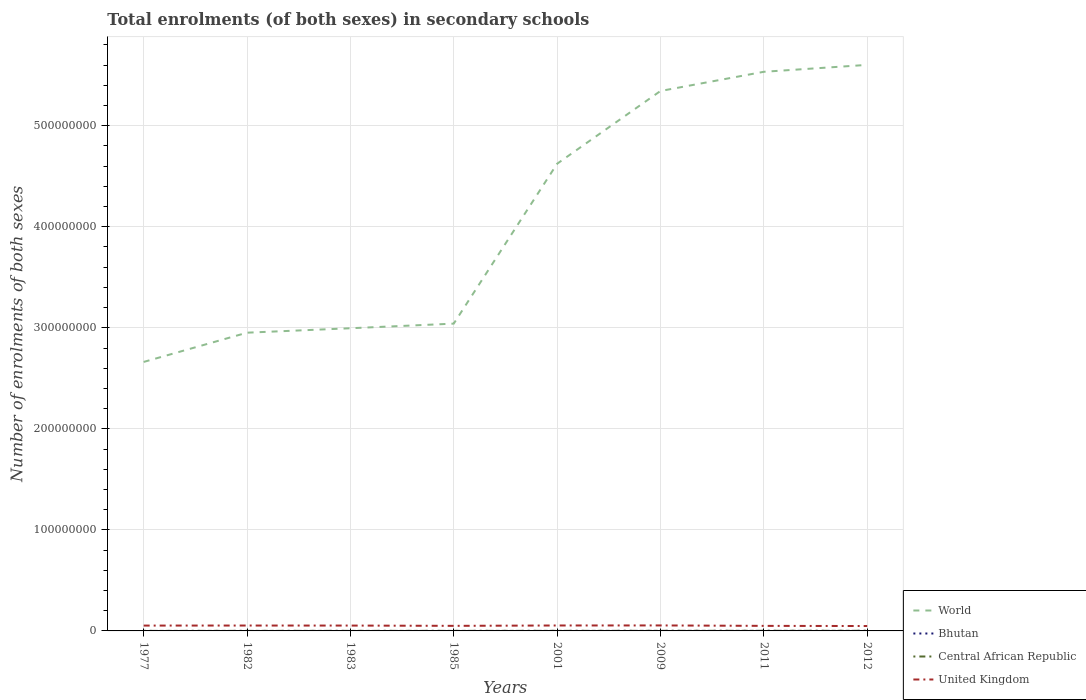How many different coloured lines are there?
Provide a short and direct response. 4. Does the line corresponding to World intersect with the line corresponding to Central African Republic?
Make the answer very short. No. Is the number of lines equal to the number of legend labels?
Offer a very short reply. Yes. Across all years, what is the maximum number of enrolments in secondary schools in World?
Offer a terse response. 2.66e+08. What is the total number of enrolments in secondary schools in World in the graph?
Give a very brief answer. -2.87e+08. What is the difference between the highest and the second highest number of enrolments in secondary schools in Bhutan?
Your answer should be compact. 6.45e+04. What is the difference between the highest and the lowest number of enrolments in secondary schools in Bhutan?
Offer a terse response. 4. How many lines are there?
Offer a very short reply. 4. What is the difference between two consecutive major ticks on the Y-axis?
Provide a short and direct response. 1.00e+08. Are the values on the major ticks of Y-axis written in scientific E-notation?
Your answer should be very brief. No. Does the graph contain grids?
Give a very brief answer. Yes. What is the title of the graph?
Ensure brevity in your answer.  Total enrolments (of both sexes) in secondary schools. What is the label or title of the X-axis?
Ensure brevity in your answer.  Years. What is the label or title of the Y-axis?
Ensure brevity in your answer.  Number of enrolments of both sexes. What is the Number of enrolments of both sexes in World in 1977?
Provide a succinct answer. 2.66e+08. What is the Number of enrolments of both sexes in Bhutan in 1977?
Ensure brevity in your answer.  1536. What is the Number of enrolments of both sexes in Central African Republic in 1977?
Give a very brief answer. 2.48e+04. What is the Number of enrolments of both sexes in United Kingdom in 1977?
Offer a very short reply. 5.29e+06. What is the Number of enrolments of both sexes in World in 1982?
Your answer should be compact. 2.95e+08. What is the Number of enrolments of both sexes in Bhutan in 1982?
Keep it short and to the point. 4408. What is the Number of enrolments of both sexes in Central African Republic in 1982?
Provide a succinct answer. 5.44e+04. What is the Number of enrolments of both sexes of United Kingdom in 1982?
Offer a very short reply. 5.33e+06. What is the Number of enrolments of both sexes of World in 1983?
Keep it short and to the point. 3.00e+08. What is the Number of enrolments of both sexes of Bhutan in 1983?
Your answer should be compact. 5298. What is the Number of enrolments of both sexes of Central African Republic in 1983?
Offer a very short reply. 5.54e+04. What is the Number of enrolments of both sexes in United Kingdom in 1983?
Give a very brief answer. 5.30e+06. What is the Number of enrolments of both sexes in World in 1985?
Provide a succinct answer. 3.04e+08. What is the Number of enrolments of both sexes in Bhutan in 1985?
Your answer should be very brief. 6094. What is the Number of enrolments of both sexes of Central African Republic in 1985?
Your answer should be very brief. 5.81e+04. What is the Number of enrolments of both sexes of United Kingdom in 1985?
Offer a terse response. 5.02e+06. What is the Number of enrolments of both sexes of World in 2001?
Your answer should be compact. 4.62e+08. What is the Number of enrolments of both sexes of Bhutan in 2001?
Provide a succinct answer. 2.91e+04. What is the Number of enrolments of both sexes in Central African Republic in 2001?
Your answer should be compact. 7.02e+04. What is the Number of enrolments of both sexes of United Kingdom in 2001?
Offer a terse response. 5.38e+06. What is the Number of enrolments of both sexes in World in 2009?
Your answer should be compact. 5.34e+08. What is the Number of enrolments of both sexes in Bhutan in 2009?
Provide a succinct answer. 5.65e+04. What is the Number of enrolments of both sexes of Central African Republic in 2009?
Make the answer very short. 9.33e+04. What is the Number of enrolments of both sexes in United Kingdom in 2009?
Make the answer very short. 5.43e+06. What is the Number of enrolments of both sexes of World in 2011?
Offer a terse response. 5.53e+08. What is the Number of enrolments of both sexes of Bhutan in 2011?
Provide a short and direct response. 6.28e+04. What is the Number of enrolments of both sexes in Central African Republic in 2011?
Give a very brief answer. 1.26e+05. What is the Number of enrolments of both sexes of United Kingdom in 2011?
Offer a very short reply. 5.00e+06. What is the Number of enrolments of both sexes of World in 2012?
Give a very brief answer. 5.60e+08. What is the Number of enrolments of both sexes of Bhutan in 2012?
Give a very brief answer. 6.61e+04. What is the Number of enrolments of both sexes of Central African Republic in 2012?
Provide a succinct answer. 1.26e+05. What is the Number of enrolments of both sexes of United Kingdom in 2012?
Give a very brief answer. 4.85e+06. Across all years, what is the maximum Number of enrolments of both sexes of World?
Ensure brevity in your answer.  5.60e+08. Across all years, what is the maximum Number of enrolments of both sexes of Bhutan?
Offer a terse response. 6.61e+04. Across all years, what is the maximum Number of enrolments of both sexes in Central African Republic?
Keep it short and to the point. 1.26e+05. Across all years, what is the maximum Number of enrolments of both sexes of United Kingdom?
Keep it short and to the point. 5.43e+06. Across all years, what is the minimum Number of enrolments of both sexes of World?
Make the answer very short. 2.66e+08. Across all years, what is the minimum Number of enrolments of both sexes of Bhutan?
Your answer should be compact. 1536. Across all years, what is the minimum Number of enrolments of both sexes of Central African Republic?
Ensure brevity in your answer.  2.48e+04. Across all years, what is the minimum Number of enrolments of both sexes in United Kingdom?
Provide a short and direct response. 4.85e+06. What is the total Number of enrolments of both sexes in World in the graph?
Offer a very short reply. 3.28e+09. What is the total Number of enrolments of both sexes in Bhutan in the graph?
Offer a very short reply. 2.32e+05. What is the total Number of enrolments of both sexes in Central African Republic in the graph?
Provide a short and direct response. 6.08e+05. What is the total Number of enrolments of both sexes in United Kingdom in the graph?
Give a very brief answer. 4.16e+07. What is the difference between the Number of enrolments of both sexes in World in 1977 and that in 1982?
Give a very brief answer. -2.89e+07. What is the difference between the Number of enrolments of both sexes in Bhutan in 1977 and that in 1982?
Provide a succinct answer. -2872. What is the difference between the Number of enrolments of both sexes of Central African Republic in 1977 and that in 1982?
Your answer should be compact. -2.96e+04. What is the difference between the Number of enrolments of both sexes in United Kingdom in 1977 and that in 1982?
Give a very brief answer. -4.41e+04. What is the difference between the Number of enrolments of both sexes of World in 1977 and that in 1983?
Offer a very short reply. -3.33e+07. What is the difference between the Number of enrolments of both sexes in Bhutan in 1977 and that in 1983?
Offer a terse response. -3762. What is the difference between the Number of enrolments of both sexes of Central African Republic in 1977 and that in 1983?
Ensure brevity in your answer.  -3.05e+04. What is the difference between the Number of enrolments of both sexes in United Kingdom in 1977 and that in 1983?
Ensure brevity in your answer.  -1.09e+04. What is the difference between the Number of enrolments of both sexes of World in 1977 and that in 1985?
Offer a terse response. -3.79e+07. What is the difference between the Number of enrolments of both sexes of Bhutan in 1977 and that in 1985?
Make the answer very short. -4558. What is the difference between the Number of enrolments of both sexes of Central African Republic in 1977 and that in 1985?
Keep it short and to the point. -3.33e+04. What is the difference between the Number of enrolments of both sexes in United Kingdom in 1977 and that in 1985?
Your response must be concise. 2.61e+05. What is the difference between the Number of enrolments of both sexes of World in 1977 and that in 2001?
Make the answer very short. -1.96e+08. What is the difference between the Number of enrolments of both sexes of Bhutan in 1977 and that in 2001?
Keep it short and to the point. -2.76e+04. What is the difference between the Number of enrolments of both sexes of Central African Republic in 1977 and that in 2001?
Give a very brief answer. -4.53e+04. What is the difference between the Number of enrolments of both sexes of United Kingdom in 1977 and that in 2001?
Offer a terse response. -9.18e+04. What is the difference between the Number of enrolments of both sexes of World in 1977 and that in 2009?
Your answer should be very brief. -2.68e+08. What is the difference between the Number of enrolments of both sexes of Bhutan in 1977 and that in 2009?
Keep it short and to the point. -5.50e+04. What is the difference between the Number of enrolments of both sexes of Central African Republic in 1977 and that in 2009?
Offer a terse response. -6.85e+04. What is the difference between the Number of enrolments of both sexes in United Kingdom in 1977 and that in 2009?
Give a very brief answer. -1.44e+05. What is the difference between the Number of enrolments of both sexes of World in 1977 and that in 2011?
Your response must be concise. -2.87e+08. What is the difference between the Number of enrolments of both sexes of Bhutan in 1977 and that in 2011?
Your answer should be compact. -6.12e+04. What is the difference between the Number of enrolments of both sexes of Central African Republic in 1977 and that in 2011?
Keep it short and to the point. -1.01e+05. What is the difference between the Number of enrolments of both sexes of United Kingdom in 1977 and that in 2011?
Give a very brief answer. 2.85e+05. What is the difference between the Number of enrolments of both sexes of World in 1977 and that in 2012?
Ensure brevity in your answer.  -2.94e+08. What is the difference between the Number of enrolments of both sexes of Bhutan in 1977 and that in 2012?
Give a very brief answer. -6.45e+04. What is the difference between the Number of enrolments of both sexes of Central African Republic in 1977 and that in 2012?
Your response must be concise. -1.01e+05. What is the difference between the Number of enrolments of both sexes of United Kingdom in 1977 and that in 2012?
Your answer should be compact. 4.36e+05. What is the difference between the Number of enrolments of both sexes in World in 1982 and that in 1983?
Ensure brevity in your answer.  -4.40e+06. What is the difference between the Number of enrolments of both sexes of Bhutan in 1982 and that in 1983?
Make the answer very short. -890. What is the difference between the Number of enrolments of both sexes of Central African Republic in 1982 and that in 1983?
Your response must be concise. -968. What is the difference between the Number of enrolments of both sexes in United Kingdom in 1982 and that in 1983?
Ensure brevity in your answer.  3.33e+04. What is the difference between the Number of enrolments of both sexes in World in 1982 and that in 1985?
Offer a terse response. -8.98e+06. What is the difference between the Number of enrolments of both sexes in Bhutan in 1982 and that in 1985?
Ensure brevity in your answer.  -1686. What is the difference between the Number of enrolments of both sexes of Central African Republic in 1982 and that in 1985?
Your response must be concise. -3704. What is the difference between the Number of enrolments of both sexes of United Kingdom in 1982 and that in 1985?
Offer a very short reply. 3.05e+05. What is the difference between the Number of enrolments of both sexes in World in 1982 and that in 2001?
Offer a very short reply. -1.67e+08. What is the difference between the Number of enrolments of both sexes of Bhutan in 1982 and that in 2001?
Make the answer very short. -2.47e+04. What is the difference between the Number of enrolments of both sexes of Central African Republic in 1982 and that in 2001?
Offer a terse response. -1.58e+04. What is the difference between the Number of enrolments of both sexes in United Kingdom in 1982 and that in 2001?
Your answer should be very brief. -4.77e+04. What is the difference between the Number of enrolments of both sexes of World in 1982 and that in 2009?
Give a very brief answer. -2.39e+08. What is the difference between the Number of enrolments of both sexes of Bhutan in 1982 and that in 2009?
Your answer should be very brief. -5.21e+04. What is the difference between the Number of enrolments of both sexes in Central African Republic in 1982 and that in 2009?
Make the answer very short. -3.89e+04. What is the difference between the Number of enrolments of both sexes of United Kingdom in 1982 and that in 2009?
Your answer should be very brief. -1.00e+05. What is the difference between the Number of enrolments of both sexes in World in 1982 and that in 2011?
Your answer should be very brief. -2.58e+08. What is the difference between the Number of enrolments of both sexes in Bhutan in 1982 and that in 2011?
Your answer should be compact. -5.84e+04. What is the difference between the Number of enrolments of both sexes in Central African Republic in 1982 and that in 2011?
Provide a succinct answer. -7.16e+04. What is the difference between the Number of enrolments of both sexes of United Kingdom in 1982 and that in 2011?
Offer a very short reply. 3.29e+05. What is the difference between the Number of enrolments of both sexes in World in 1982 and that in 2012?
Keep it short and to the point. -2.65e+08. What is the difference between the Number of enrolments of both sexes in Bhutan in 1982 and that in 2012?
Ensure brevity in your answer.  -6.17e+04. What is the difference between the Number of enrolments of both sexes of Central African Republic in 1982 and that in 2012?
Offer a terse response. -7.15e+04. What is the difference between the Number of enrolments of both sexes in United Kingdom in 1982 and that in 2012?
Give a very brief answer. 4.80e+05. What is the difference between the Number of enrolments of both sexes in World in 1983 and that in 1985?
Give a very brief answer. -4.58e+06. What is the difference between the Number of enrolments of both sexes of Bhutan in 1983 and that in 1985?
Give a very brief answer. -796. What is the difference between the Number of enrolments of both sexes of Central African Republic in 1983 and that in 1985?
Your answer should be very brief. -2736. What is the difference between the Number of enrolments of both sexes of United Kingdom in 1983 and that in 1985?
Keep it short and to the point. 2.72e+05. What is the difference between the Number of enrolments of both sexes of World in 1983 and that in 2001?
Give a very brief answer. -1.63e+08. What is the difference between the Number of enrolments of both sexes of Bhutan in 1983 and that in 2001?
Offer a very short reply. -2.38e+04. What is the difference between the Number of enrolments of both sexes of Central African Republic in 1983 and that in 2001?
Keep it short and to the point. -1.48e+04. What is the difference between the Number of enrolments of both sexes in United Kingdom in 1983 and that in 2001?
Offer a terse response. -8.10e+04. What is the difference between the Number of enrolments of both sexes of World in 1983 and that in 2009?
Your answer should be very brief. -2.35e+08. What is the difference between the Number of enrolments of both sexes of Bhutan in 1983 and that in 2009?
Your answer should be very brief. -5.12e+04. What is the difference between the Number of enrolments of both sexes in Central African Republic in 1983 and that in 2009?
Offer a very short reply. -3.80e+04. What is the difference between the Number of enrolments of both sexes in United Kingdom in 1983 and that in 2009?
Your answer should be compact. -1.34e+05. What is the difference between the Number of enrolments of both sexes of World in 1983 and that in 2011?
Your answer should be very brief. -2.54e+08. What is the difference between the Number of enrolments of both sexes in Bhutan in 1983 and that in 2011?
Keep it short and to the point. -5.75e+04. What is the difference between the Number of enrolments of both sexes in Central African Republic in 1983 and that in 2011?
Your response must be concise. -7.06e+04. What is the difference between the Number of enrolments of both sexes in United Kingdom in 1983 and that in 2011?
Your answer should be compact. 2.96e+05. What is the difference between the Number of enrolments of both sexes of World in 1983 and that in 2012?
Your answer should be compact. -2.61e+08. What is the difference between the Number of enrolments of both sexes in Bhutan in 1983 and that in 2012?
Your response must be concise. -6.08e+04. What is the difference between the Number of enrolments of both sexes of Central African Republic in 1983 and that in 2012?
Offer a terse response. -7.05e+04. What is the difference between the Number of enrolments of both sexes of United Kingdom in 1983 and that in 2012?
Give a very brief answer. 4.47e+05. What is the difference between the Number of enrolments of both sexes in World in 1985 and that in 2001?
Your answer should be compact. -1.58e+08. What is the difference between the Number of enrolments of both sexes of Bhutan in 1985 and that in 2001?
Your answer should be very brief. -2.30e+04. What is the difference between the Number of enrolments of both sexes of Central African Republic in 1985 and that in 2001?
Give a very brief answer. -1.21e+04. What is the difference between the Number of enrolments of both sexes in United Kingdom in 1985 and that in 2001?
Provide a succinct answer. -3.53e+05. What is the difference between the Number of enrolments of both sexes of World in 1985 and that in 2009?
Offer a very short reply. -2.30e+08. What is the difference between the Number of enrolments of both sexes of Bhutan in 1985 and that in 2009?
Provide a short and direct response. -5.04e+04. What is the difference between the Number of enrolments of both sexes in Central African Republic in 1985 and that in 2009?
Your answer should be very brief. -3.52e+04. What is the difference between the Number of enrolments of both sexes of United Kingdom in 1985 and that in 2009?
Keep it short and to the point. -4.06e+05. What is the difference between the Number of enrolments of both sexes in World in 1985 and that in 2011?
Keep it short and to the point. -2.49e+08. What is the difference between the Number of enrolments of both sexes of Bhutan in 1985 and that in 2011?
Your answer should be compact. -5.67e+04. What is the difference between the Number of enrolments of both sexes in Central African Republic in 1985 and that in 2011?
Provide a short and direct response. -6.79e+04. What is the difference between the Number of enrolments of both sexes of United Kingdom in 1985 and that in 2011?
Provide a succinct answer. 2.37e+04. What is the difference between the Number of enrolments of both sexes of World in 1985 and that in 2012?
Your answer should be compact. -2.56e+08. What is the difference between the Number of enrolments of both sexes in Bhutan in 1985 and that in 2012?
Offer a terse response. -6.00e+04. What is the difference between the Number of enrolments of both sexes of Central African Republic in 1985 and that in 2012?
Provide a short and direct response. -6.78e+04. What is the difference between the Number of enrolments of both sexes of United Kingdom in 1985 and that in 2012?
Offer a terse response. 1.75e+05. What is the difference between the Number of enrolments of both sexes of World in 2001 and that in 2009?
Offer a terse response. -7.20e+07. What is the difference between the Number of enrolments of both sexes in Bhutan in 2001 and that in 2009?
Offer a terse response. -2.74e+04. What is the difference between the Number of enrolments of both sexes in Central African Republic in 2001 and that in 2009?
Offer a terse response. -2.32e+04. What is the difference between the Number of enrolments of both sexes of United Kingdom in 2001 and that in 2009?
Make the answer very short. -5.27e+04. What is the difference between the Number of enrolments of both sexes in World in 2001 and that in 2011?
Give a very brief answer. -9.10e+07. What is the difference between the Number of enrolments of both sexes in Bhutan in 2001 and that in 2011?
Ensure brevity in your answer.  -3.37e+04. What is the difference between the Number of enrolments of both sexes in Central African Republic in 2001 and that in 2011?
Your answer should be compact. -5.59e+04. What is the difference between the Number of enrolments of both sexes in United Kingdom in 2001 and that in 2011?
Make the answer very short. 3.77e+05. What is the difference between the Number of enrolments of both sexes of World in 2001 and that in 2012?
Make the answer very short. -9.79e+07. What is the difference between the Number of enrolments of both sexes of Bhutan in 2001 and that in 2012?
Provide a succinct answer. -3.70e+04. What is the difference between the Number of enrolments of both sexes in Central African Republic in 2001 and that in 2012?
Give a very brief answer. -5.57e+04. What is the difference between the Number of enrolments of both sexes of United Kingdom in 2001 and that in 2012?
Your answer should be very brief. 5.28e+05. What is the difference between the Number of enrolments of both sexes of World in 2009 and that in 2011?
Provide a short and direct response. -1.90e+07. What is the difference between the Number of enrolments of both sexes of Bhutan in 2009 and that in 2011?
Your answer should be very brief. -6225. What is the difference between the Number of enrolments of both sexes of Central African Republic in 2009 and that in 2011?
Make the answer very short. -3.27e+04. What is the difference between the Number of enrolments of both sexes of United Kingdom in 2009 and that in 2011?
Keep it short and to the point. 4.29e+05. What is the difference between the Number of enrolments of both sexes in World in 2009 and that in 2012?
Make the answer very short. -2.58e+07. What is the difference between the Number of enrolments of both sexes of Bhutan in 2009 and that in 2012?
Keep it short and to the point. -9529. What is the difference between the Number of enrolments of both sexes of Central African Republic in 2009 and that in 2012?
Offer a terse response. -3.26e+04. What is the difference between the Number of enrolments of both sexes of United Kingdom in 2009 and that in 2012?
Keep it short and to the point. 5.80e+05. What is the difference between the Number of enrolments of both sexes in World in 2011 and that in 2012?
Provide a short and direct response. -6.84e+06. What is the difference between the Number of enrolments of both sexes in Bhutan in 2011 and that in 2012?
Your response must be concise. -3304. What is the difference between the Number of enrolments of both sexes in Central African Republic in 2011 and that in 2012?
Provide a short and direct response. 110. What is the difference between the Number of enrolments of both sexes in United Kingdom in 2011 and that in 2012?
Make the answer very short. 1.51e+05. What is the difference between the Number of enrolments of both sexes in World in 1977 and the Number of enrolments of both sexes in Bhutan in 1982?
Ensure brevity in your answer.  2.66e+08. What is the difference between the Number of enrolments of both sexes in World in 1977 and the Number of enrolments of both sexes in Central African Republic in 1982?
Keep it short and to the point. 2.66e+08. What is the difference between the Number of enrolments of both sexes of World in 1977 and the Number of enrolments of both sexes of United Kingdom in 1982?
Keep it short and to the point. 2.61e+08. What is the difference between the Number of enrolments of both sexes of Bhutan in 1977 and the Number of enrolments of both sexes of Central African Republic in 1982?
Ensure brevity in your answer.  -5.29e+04. What is the difference between the Number of enrolments of both sexes in Bhutan in 1977 and the Number of enrolments of both sexes in United Kingdom in 1982?
Your answer should be compact. -5.33e+06. What is the difference between the Number of enrolments of both sexes of Central African Republic in 1977 and the Number of enrolments of both sexes of United Kingdom in 1982?
Offer a terse response. -5.30e+06. What is the difference between the Number of enrolments of both sexes of World in 1977 and the Number of enrolments of both sexes of Bhutan in 1983?
Provide a succinct answer. 2.66e+08. What is the difference between the Number of enrolments of both sexes of World in 1977 and the Number of enrolments of both sexes of Central African Republic in 1983?
Offer a terse response. 2.66e+08. What is the difference between the Number of enrolments of both sexes of World in 1977 and the Number of enrolments of both sexes of United Kingdom in 1983?
Your answer should be compact. 2.61e+08. What is the difference between the Number of enrolments of both sexes of Bhutan in 1977 and the Number of enrolments of both sexes of Central African Republic in 1983?
Give a very brief answer. -5.38e+04. What is the difference between the Number of enrolments of both sexes in Bhutan in 1977 and the Number of enrolments of both sexes in United Kingdom in 1983?
Keep it short and to the point. -5.29e+06. What is the difference between the Number of enrolments of both sexes in Central African Republic in 1977 and the Number of enrolments of both sexes in United Kingdom in 1983?
Provide a short and direct response. -5.27e+06. What is the difference between the Number of enrolments of both sexes of World in 1977 and the Number of enrolments of both sexes of Bhutan in 1985?
Your answer should be compact. 2.66e+08. What is the difference between the Number of enrolments of both sexes in World in 1977 and the Number of enrolments of both sexes in Central African Republic in 1985?
Keep it short and to the point. 2.66e+08. What is the difference between the Number of enrolments of both sexes of World in 1977 and the Number of enrolments of both sexes of United Kingdom in 1985?
Your response must be concise. 2.61e+08. What is the difference between the Number of enrolments of both sexes of Bhutan in 1977 and the Number of enrolments of both sexes of Central African Republic in 1985?
Your answer should be very brief. -5.66e+04. What is the difference between the Number of enrolments of both sexes in Bhutan in 1977 and the Number of enrolments of both sexes in United Kingdom in 1985?
Your answer should be compact. -5.02e+06. What is the difference between the Number of enrolments of both sexes in Central African Republic in 1977 and the Number of enrolments of both sexes in United Kingdom in 1985?
Your answer should be very brief. -5.00e+06. What is the difference between the Number of enrolments of both sexes in World in 1977 and the Number of enrolments of both sexes in Bhutan in 2001?
Provide a short and direct response. 2.66e+08. What is the difference between the Number of enrolments of both sexes in World in 1977 and the Number of enrolments of both sexes in Central African Republic in 2001?
Your answer should be compact. 2.66e+08. What is the difference between the Number of enrolments of both sexes of World in 1977 and the Number of enrolments of both sexes of United Kingdom in 2001?
Your response must be concise. 2.61e+08. What is the difference between the Number of enrolments of both sexes in Bhutan in 1977 and the Number of enrolments of both sexes in Central African Republic in 2001?
Offer a very short reply. -6.86e+04. What is the difference between the Number of enrolments of both sexes in Bhutan in 1977 and the Number of enrolments of both sexes in United Kingdom in 2001?
Provide a succinct answer. -5.38e+06. What is the difference between the Number of enrolments of both sexes in Central African Republic in 1977 and the Number of enrolments of both sexes in United Kingdom in 2001?
Your answer should be compact. -5.35e+06. What is the difference between the Number of enrolments of both sexes in World in 1977 and the Number of enrolments of both sexes in Bhutan in 2009?
Your response must be concise. 2.66e+08. What is the difference between the Number of enrolments of both sexes in World in 1977 and the Number of enrolments of both sexes in Central African Republic in 2009?
Keep it short and to the point. 2.66e+08. What is the difference between the Number of enrolments of both sexes of World in 1977 and the Number of enrolments of both sexes of United Kingdom in 2009?
Keep it short and to the point. 2.61e+08. What is the difference between the Number of enrolments of both sexes in Bhutan in 1977 and the Number of enrolments of both sexes in Central African Republic in 2009?
Provide a succinct answer. -9.18e+04. What is the difference between the Number of enrolments of both sexes in Bhutan in 1977 and the Number of enrolments of both sexes in United Kingdom in 2009?
Keep it short and to the point. -5.43e+06. What is the difference between the Number of enrolments of both sexes of Central African Republic in 1977 and the Number of enrolments of both sexes of United Kingdom in 2009?
Your answer should be very brief. -5.40e+06. What is the difference between the Number of enrolments of both sexes of World in 1977 and the Number of enrolments of both sexes of Bhutan in 2011?
Provide a succinct answer. 2.66e+08. What is the difference between the Number of enrolments of both sexes of World in 1977 and the Number of enrolments of both sexes of Central African Republic in 2011?
Your answer should be compact. 2.66e+08. What is the difference between the Number of enrolments of both sexes of World in 1977 and the Number of enrolments of both sexes of United Kingdom in 2011?
Make the answer very short. 2.61e+08. What is the difference between the Number of enrolments of both sexes of Bhutan in 1977 and the Number of enrolments of both sexes of Central African Republic in 2011?
Provide a succinct answer. -1.24e+05. What is the difference between the Number of enrolments of both sexes in Bhutan in 1977 and the Number of enrolments of both sexes in United Kingdom in 2011?
Provide a short and direct response. -5.00e+06. What is the difference between the Number of enrolments of both sexes in Central African Republic in 1977 and the Number of enrolments of both sexes in United Kingdom in 2011?
Offer a terse response. -4.98e+06. What is the difference between the Number of enrolments of both sexes of World in 1977 and the Number of enrolments of both sexes of Bhutan in 2012?
Make the answer very short. 2.66e+08. What is the difference between the Number of enrolments of both sexes of World in 1977 and the Number of enrolments of both sexes of Central African Republic in 2012?
Your response must be concise. 2.66e+08. What is the difference between the Number of enrolments of both sexes of World in 1977 and the Number of enrolments of both sexes of United Kingdom in 2012?
Make the answer very short. 2.61e+08. What is the difference between the Number of enrolments of both sexes of Bhutan in 1977 and the Number of enrolments of both sexes of Central African Republic in 2012?
Your response must be concise. -1.24e+05. What is the difference between the Number of enrolments of both sexes of Bhutan in 1977 and the Number of enrolments of both sexes of United Kingdom in 2012?
Your response must be concise. -4.85e+06. What is the difference between the Number of enrolments of both sexes in Central African Republic in 1977 and the Number of enrolments of both sexes in United Kingdom in 2012?
Give a very brief answer. -4.82e+06. What is the difference between the Number of enrolments of both sexes in World in 1982 and the Number of enrolments of both sexes in Bhutan in 1983?
Provide a succinct answer. 2.95e+08. What is the difference between the Number of enrolments of both sexes of World in 1982 and the Number of enrolments of both sexes of Central African Republic in 1983?
Your answer should be compact. 2.95e+08. What is the difference between the Number of enrolments of both sexes in World in 1982 and the Number of enrolments of both sexes in United Kingdom in 1983?
Provide a short and direct response. 2.90e+08. What is the difference between the Number of enrolments of both sexes of Bhutan in 1982 and the Number of enrolments of both sexes of Central African Republic in 1983?
Make the answer very short. -5.10e+04. What is the difference between the Number of enrolments of both sexes of Bhutan in 1982 and the Number of enrolments of both sexes of United Kingdom in 1983?
Your answer should be very brief. -5.29e+06. What is the difference between the Number of enrolments of both sexes of Central African Republic in 1982 and the Number of enrolments of both sexes of United Kingdom in 1983?
Ensure brevity in your answer.  -5.24e+06. What is the difference between the Number of enrolments of both sexes in World in 1982 and the Number of enrolments of both sexes in Bhutan in 1985?
Offer a very short reply. 2.95e+08. What is the difference between the Number of enrolments of both sexes in World in 1982 and the Number of enrolments of both sexes in Central African Republic in 1985?
Make the answer very short. 2.95e+08. What is the difference between the Number of enrolments of both sexes of World in 1982 and the Number of enrolments of both sexes of United Kingdom in 1985?
Your answer should be very brief. 2.90e+08. What is the difference between the Number of enrolments of both sexes of Bhutan in 1982 and the Number of enrolments of both sexes of Central African Republic in 1985?
Offer a terse response. -5.37e+04. What is the difference between the Number of enrolments of both sexes in Bhutan in 1982 and the Number of enrolments of both sexes in United Kingdom in 1985?
Offer a terse response. -5.02e+06. What is the difference between the Number of enrolments of both sexes in Central African Republic in 1982 and the Number of enrolments of both sexes in United Kingdom in 1985?
Provide a succinct answer. -4.97e+06. What is the difference between the Number of enrolments of both sexes of World in 1982 and the Number of enrolments of both sexes of Bhutan in 2001?
Provide a succinct answer. 2.95e+08. What is the difference between the Number of enrolments of both sexes of World in 1982 and the Number of enrolments of both sexes of Central African Republic in 2001?
Provide a succinct answer. 2.95e+08. What is the difference between the Number of enrolments of both sexes of World in 1982 and the Number of enrolments of both sexes of United Kingdom in 2001?
Your response must be concise. 2.90e+08. What is the difference between the Number of enrolments of both sexes in Bhutan in 1982 and the Number of enrolments of both sexes in Central African Republic in 2001?
Make the answer very short. -6.58e+04. What is the difference between the Number of enrolments of both sexes in Bhutan in 1982 and the Number of enrolments of both sexes in United Kingdom in 2001?
Your answer should be very brief. -5.37e+06. What is the difference between the Number of enrolments of both sexes of Central African Republic in 1982 and the Number of enrolments of both sexes of United Kingdom in 2001?
Offer a very short reply. -5.32e+06. What is the difference between the Number of enrolments of both sexes of World in 1982 and the Number of enrolments of both sexes of Bhutan in 2009?
Provide a short and direct response. 2.95e+08. What is the difference between the Number of enrolments of both sexes of World in 1982 and the Number of enrolments of both sexes of Central African Republic in 2009?
Give a very brief answer. 2.95e+08. What is the difference between the Number of enrolments of both sexes in World in 1982 and the Number of enrolments of both sexes in United Kingdom in 2009?
Keep it short and to the point. 2.90e+08. What is the difference between the Number of enrolments of both sexes of Bhutan in 1982 and the Number of enrolments of both sexes of Central African Republic in 2009?
Give a very brief answer. -8.89e+04. What is the difference between the Number of enrolments of both sexes of Bhutan in 1982 and the Number of enrolments of both sexes of United Kingdom in 2009?
Your response must be concise. -5.43e+06. What is the difference between the Number of enrolments of both sexes in Central African Republic in 1982 and the Number of enrolments of both sexes in United Kingdom in 2009?
Keep it short and to the point. -5.38e+06. What is the difference between the Number of enrolments of both sexes in World in 1982 and the Number of enrolments of both sexes in Bhutan in 2011?
Keep it short and to the point. 2.95e+08. What is the difference between the Number of enrolments of both sexes in World in 1982 and the Number of enrolments of both sexes in Central African Republic in 2011?
Give a very brief answer. 2.95e+08. What is the difference between the Number of enrolments of both sexes in World in 1982 and the Number of enrolments of both sexes in United Kingdom in 2011?
Your answer should be compact. 2.90e+08. What is the difference between the Number of enrolments of both sexes of Bhutan in 1982 and the Number of enrolments of both sexes of Central African Republic in 2011?
Offer a very short reply. -1.22e+05. What is the difference between the Number of enrolments of both sexes of Bhutan in 1982 and the Number of enrolments of both sexes of United Kingdom in 2011?
Make the answer very short. -5.00e+06. What is the difference between the Number of enrolments of both sexes in Central African Republic in 1982 and the Number of enrolments of both sexes in United Kingdom in 2011?
Your response must be concise. -4.95e+06. What is the difference between the Number of enrolments of both sexes in World in 1982 and the Number of enrolments of both sexes in Bhutan in 2012?
Your answer should be compact. 2.95e+08. What is the difference between the Number of enrolments of both sexes of World in 1982 and the Number of enrolments of both sexes of Central African Republic in 2012?
Give a very brief answer. 2.95e+08. What is the difference between the Number of enrolments of both sexes of World in 1982 and the Number of enrolments of both sexes of United Kingdom in 2012?
Provide a short and direct response. 2.90e+08. What is the difference between the Number of enrolments of both sexes in Bhutan in 1982 and the Number of enrolments of both sexes in Central African Republic in 2012?
Offer a very short reply. -1.21e+05. What is the difference between the Number of enrolments of both sexes of Bhutan in 1982 and the Number of enrolments of both sexes of United Kingdom in 2012?
Your answer should be compact. -4.84e+06. What is the difference between the Number of enrolments of both sexes in Central African Republic in 1982 and the Number of enrolments of both sexes in United Kingdom in 2012?
Your answer should be very brief. -4.79e+06. What is the difference between the Number of enrolments of both sexes of World in 1983 and the Number of enrolments of both sexes of Bhutan in 1985?
Make the answer very short. 3.00e+08. What is the difference between the Number of enrolments of both sexes of World in 1983 and the Number of enrolments of both sexes of Central African Republic in 1985?
Provide a short and direct response. 3.00e+08. What is the difference between the Number of enrolments of both sexes in World in 1983 and the Number of enrolments of both sexes in United Kingdom in 1985?
Keep it short and to the point. 2.95e+08. What is the difference between the Number of enrolments of both sexes of Bhutan in 1983 and the Number of enrolments of both sexes of Central African Republic in 1985?
Offer a very short reply. -5.28e+04. What is the difference between the Number of enrolments of both sexes of Bhutan in 1983 and the Number of enrolments of both sexes of United Kingdom in 1985?
Your answer should be very brief. -5.02e+06. What is the difference between the Number of enrolments of both sexes in Central African Republic in 1983 and the Number of enrolments of both sexes in United Kingdom in 1985?
Give a very brief answer. -4.97e+06. What is the difference between the Number of enrolments of both sexes of World in 1983 and the Number of enrolments of both sexes of Bhutan in 2001?
Ensure brevity in your answer.  3.00e+08. What is the difference between the Number of enrolments of both sexes in World in 1983 and the Number of enrolments of both sexes in Central African Republic in 2001?
Offer a very short reply. 2.99e+08. What is the difference between the Number of enrolments of both sexes in World in 1983 and the Number of enrolments of both sexes in United Kingdom in 2001?
Provide a succinct answer. 2.94e+08. What is the difference between the Number of enrolments of both sexes of Bhutan in 1983 and the Number of enrolments of both sexes of Central African Republic in 2001?
Offer a very short reply. -6.49e+04. What is the difference between the Number of enrolments of both sexes in Bhutan in 1983 and the Number of enrolments of both sexes in United Kingdom in 2001?
Make the answer very short. -5.37e+06. What is the difference between the Number of enrolments of both sexes of Central African Republic in 1983 and the Number of enrolments of both sexes of United Kingdom in 2001?
Provide a short and direct response. -5.32e+06. What is the difference between the Number of enrolments of both sexes in World in 1983 and the Number of enrolments of both sexes in Bhutan in 2009?
Provide a succinct answer. 3.00e+08. What is the difference between the Number of enrolments of both sexes in World in 1983 and the Number of enrolments of both sexes in Central African Republic in 2009?
Your response must be concise. 2.99e+08. What is the difference between the Number of enrolments of both sexes in World in 1983 and the Number of enrolments of both sexes in United Kingdom in 2009?
Your answer should be compact. 2.94e+08. What is the difference between the Number of enrolments of both sexes of Bhutan in 1983 and the Number of enrolments of both sexes of Central African Republic in 2009?
Your answer should be compact. -8.80e+04. What is the difference between the Number of enrolments of both sexes of Bhutan in 1983 and the Number of enrolments of both sexes of United Kingdom in 2009?
Ensure brevity in your answer.  -5.42e+06. What is the difference between the Number of enrolments of both sexes of Central African Republic in 1983 and the Number of enrolments of both sexes of United Kingdom in 2009?
Your answer should be compact. -5.37e+06. What is the difference between the Number of enrolments of both sexes of World in 1983 and the Number of enrolments of both sexes of Bhutan in 2011?
Offer a very short reply. 2.99e+08. What is the difference between the Number of enrolments of both sexes of World in 1983 and the Number of enrolments of both sexes of Central African Republic in 2011?
Ensure brevity in your answer.  2.99e+08. What is the difference between the Number of enrolments of both sexes in World in 1983 and the Number of enrolments of both sexes in United Kingdom in 2011?
Make the answer very short. 2.95e+08. What is the difference between the Number of enrolments of both sexes of Bhutan in 1983 and the Number of enrolments of both sexes of Central African Republic in 2011?
Your answer should be very brief. -1.21e+05. What is the difference between the Number of enrolments of both sexes of Bhutan in 1983 and the Number of enrolments of both sexes of United Kingdom in 2011?
Keep it short and to the point. -5.00e+06. What is the difference between the Number of enrolments of both sexes of Central African Republic in 1983 and the Number of enrolments of both sexes of United Kingdom in 2011?
Provide a succinct answer. -4.94e+06. What is the difference between the Number of enrolments of both sexes in World in 1983 and the Number of enrolments of both sexes in Bhutan in 2012?
Your answer should be very brief. 2.99e+08. What is the difference between the Number of enrolments of both sexes of World in 1983 and the Number of enrolments of both sexes of Central African Republic in 2012?
Offer a very short reply. 2.99e+08. What is the difference between the Number of enrolments of both sexes of World in 1983 and the Number of enrolments of both sexes of United Kingdom in 2012?
Offer a very short reply. 2.95e+08. What is the difference between the Number of enrolments of both sexes in Bhutan in 1983 and the Number of enrolments of both sexes in Central African Republic in 2012?
Provide a succinct answer. -1.21e+05. What is the difference between the Number of enrolments of both sexes in Bhutan in 1983 and the Number of enrolments of both sexes in United Kingdom in 2012?
Your answer should be compact. -4.84e+06. What is the difference between the Number of enrolments of both sexes in Central African Republic in 1983 and the Number of enrolments of both sexes in United Kingdom in 2012?
Your response must be concise. -4.79e+06. What is the difference between the Number of enrolments of both sexes of World in 1985 and the Number of enrolments of both sexes of Bhutan in 2001?
Provide a succinct answer. 3.04e+08. What is the difference between the Number of enrolments of both sexes of World in 1985 and the Number of enrolments of both sexes of Central African Republic in 2001?
Give a very brief answer. 3.04e+08. What is the difference between the Number of enrolments of both sexes of World in 1985 and the Number of enrolments of both sexes of United Kingdom in 2001?
Make the answer very short. 2.99e+08. What is the difference between the Number of enrolments of both sexes in Bhutan in 1985 and the Number of enrolments of both sexes in Central African Republic in 2001?
Keep it short and to the point. -6.41e+04. What is the difference between the Number of enrolments of both sexes in Bhutan in 1985 and the Number of enrolments of both sexes in United Kingdom in 2001?
Provide a short and direct response. -5.37e+06. What is the difference between the Number of enrolments of both sexes in Central African Republic in 1985 and the Number of enrolments of both sexes in United Kingdom in 2001?
Keep it short and to the point. -5.32e+06. What is the difference between the Number of enrolments of both sexes of World in 1985 and the Number of enrolments of both sexes of Bhutan in 2009?
Offer a terse response. 3.04e+08. What is the difference between the Number of enrolments of both sexes in World in 1985 and the Number of enrolments of both sexes in Central African Republic in 2009?
Make the answer very short. 3.04e+08. What is the difference between the Number of enrolments of both sexes of World in 1985 and the Number of enrolments of both sexes of United Kingdom in 2009?
Provide a succinct answer. 2.99e+08. What is the difference between the Number of enrolments of both sexes in Bhutan in 1985 and the Number of enrolments of both sexes in Central African Republic in 2009?
Your answer should be compact. -8.72e+04. What is the difference between the Number of enrolments of both sexes of Bhutan in 1985 and the Number of enrolments of both sexes of United Kingdom in 2009?
Your answer should be very brief. -5.42e+06. What is the difference between the Number of enrolments of both sexes of Central African Republic in 1985 and the Number of enrolments of both sexes of United Kingdom in 2009?
Provide a short and direct response. -5.37e+06. What is the difference between the Number of enrolments of both sexes of World in 1985 and the Number of enrolments of both sexes of Bhutan in 2011?
Offer a terse response. 3.04e+08. What is the difference between the Number of enrolments of both sexes of World in 1985 and the Number of enrolments of both sexes of Central African Republic in 2011?
Provide a succinct answer. 3.04e+08. What is the difference between the Number of enrolments of both sexes of World in 1985 and the Number of enrolments of both sexes of United Kingdom in 2011?
Ensure brevity in your answer.  2.99e+08. What is the difference between the Number of enrolments of both sexes of Bhutan in 1985 and the Number of enrolments of both sexes of Central African Republic in 2011?
Make the answer very short. -1.20e+05. What is the difference between the Number of enrolments of both sexes of Bhutan in 1985 and the Number of enrolments of both sexes of United Kingdom in 2011?
Give a very brief answer. -4.99e+06. What is the difference between the Number of enrolments of both sexes of Central African Republic in 1985 and the Number of enrolments of both sexes of United Kingdom in 2011?
Ensure brevity in your answer.  -4.94e+06. What is the difference between the Number of enrolments of both sexes in World in 1985 and the Number of enrolments of both sexes in Bhutan in 2012?
Offer a terse response. 3.04e+08. What is the difference between the Number of enrolments of both sexes in World in 1985 and the Number of enrolments of both sexes in Central African Republic in 2012?
Your answer should be very brief. 3.04e+08. What is the difference between the Number of enrolments of both sexes of World in 1985 and the Number of enrolments of both sexes of United Kingdom in 2012?
Your response must be concise. 2.99e+08. What is the difference between the Number of enrolments of both sexes of Bhutan in 1985 and the Number of enrolments of both sexes of Central African Republic in 2012?
Provide a succinct answer. -1.20e+05. What is the difference between the Number of enrolments of both sexes of Bhutan in 1985 and the Number of enrolments of both sexes of United Kingdom in 2012?
Your answer should be very brief. -4.84e+06. What is the difference between the Number of enrolments of both sexes of Central African Republic in 1985 and the Number of enrolments of both sexes of United Kingdom in 2012?
Offer a very short reply. -4.79e+06. What is the difference between the Number of enrolments of both sexes of World in 2001 and the Number of enrolments of both sexes of Bhutan in 2009?
Give a very brief answer. 4.62e+08. What is the difference between the Number of enrolments of both sexes of World in 2001 and the Number of enrolments of both sexes of Central African Republic in 2009?
Your response must be concise. 4.62e+08. What is the difference between the Number of enrolments of both sexes in World in 2001 and the Number of enrolments of both sexes in United Kingdom in 2009?
Keep it short and to the point. 4.57e+08. What is the difference between the Number of enrolments of both sexes of Bhutan in 2001 and the Number of enrolments of both sexes of Central African Republic in 2009?
Make the answer very short. -6.42e+04. What is the difference between the Number of enrolments of both sexes in Bhutan in 2001 and the Number of enrolments of both sexes in United Kingdom in 2009?
Offer a very short reply. -5.40e+06. What is the difference between the Number of enrolments of both sexes of Central African Republic in 2001 and the Number of enrolments of both sexes of United Kingdom in 2009?
Your answer should be compact. -5.36e+06. What is the difference between the Number of enrolments of both sexes in World in 2001 and the Number of enrolments of both sexes in Bhutan in 2011?
Make the answer very short. 4.62e+08. What is the difference between the Number of enrolments of both sexes of World in 2001 and the Number of enrolments of both sexes of Central African Republic in 2011?
Your answer should be compact. 4.62e+08. What is the difference between the Number of enrolments of both sexes in World in 2001 and the Number of enrolments of both sexes in United Kingdom in 2011?
Offer a terse response. 4.57e+08. What is the difference between the Number of enrolments of both sexes in Bhutan in 2001 and the Number of enrolments of both sexes in Central African Republic in 2011?
Ensure brevity in your answer.  -9.69e+04. What is the difference between the Number of enrolments of both sexes in Bhutan in 2001 and the Number of enrolments of both sexes in United Kingdom in 2011?
Your answer should be compact. -4.97e+06. What is the difference between the Number of enrolments of both sexes in Central African Republic in 2001 and the Number of enrolments of both sexes in United Kingdom in 2011?
Ensure brevity in your answer.  -4.93e+06. What is the difference between the Number of enrolments of both sexes of World in 2001 and the Number of enrolments of both sexes of Bhutan in 2012?
Your answer should be very brief. 4.62e+08. What is the difference between the Number of enrolments of both sexes in World in 2001 and the Number of enrolments of both sexes in Central African Republic in 2012?
Your answer should be compact. 4.62e+08. What is the difference between the Number of enrolments of both sexes of World in 2001 and the Number of enrolments of both sexes of United Kingdom in 2012?
Your answer should be very brief. 4.58e+08. What is the difference between the Number of enrolments of both sexes of Bhutan in 2001 and the Number of enrolments of both sexes of Central African Republic in 2012?
Your response must be concise. -9.68e+04. What is the difference between the Number of enrolments of both sexes of Bhutan in 2001 and the Number of enrolments of both sexes of United Kingdom in 2012?
Keep it short and to the point. -4.82e+06. What is the difference between the Number of enrolments of both sexes of Central African Republic in 2001 and the Number of enrolments of both sexes of United Kingdom in 2012?
Provide a short and direct response. -4.78e+06. What is the difference between the Number of enrolments of both sexes of World in 2009 and the Number of enrolments of both sexes of Bhutan in 2011?
Offer a very short reply. 5.34e+08. What is the difference between the Number of enrolments of both sexes of World in 2009 and the Number of enrolments of both sexes of Central African Republic in 2011?
Offer a terse response. 5.34e+08. What is the difference between the Number of enrolments of both sexes in World in 2009 and the Number of enrolments of both sexes in United Kingdom in 2011?
Offer a very short reply. 5.29e+08. What is the difference between the Number of enrolments of both sexes in Bhutan in 2009 and the Number of enrolments of both sexes in Central African Republic in 2011?
Make the answer very short. -6.95e+04. What is the difference between the Number of enrolments of both sexes of Bhutan in 2009 and the Number of enrolments of both sexes of United Kingdom in 2011?
Provide a succinct answer. -4.94e+06. What is the difference between the Number of enrolments of both sexes in Central African Republic in 2009 and the Number of enrolments of both sexes in United Kingdom in 2011?
Provide a short and direct response. -4.91e+06. What is the difference between the Number of enrolments of both sexes of World in 2009 and the Number of enrolments of both sexes of Bhutan in 2012?
Offer a terse response. 5.34e+08. What is the difference between the Number of enrolments of both sexes of World in 2009 and the Number of enrolments of both sexes of Central African Republic in 2012?
Your answer should be compact. 5.34e+08. What is the difference between the Number of enrolments of both sexes of World in 2009 and the Number of enrolments of both sexes of United Kingdom in 2012?
Offer a very short reply. 5.30e+08. What is the difference between the Number of enrolments of both sexes of Bhutan in 2009 and the Number of enrolments of both sexes of Central African Republic in 2012?
Your answer should be very brief. -6.94e+04. What is the difference between the Number of enrolments of both sexes of Bhutan in 2009 and the Number of enrolments of both sexes of United Kingdom in 2012?
Keep it short and to the point. -4.79e+06. What is the difference between the Number of enrolments of both sexes in Central African Republic in 2009 and the Number of enrolments of both sexes in United Kingdom in 2012?
Make the answer very short. -4.76e+06. What is the difference between the Number of enrolments of both sexes of World in 2011 and the Number of enrolments of both sexes of Bhutan in 2012?
Keep it short and to the point. 5.53e+08. What is the difference between the Number of enrolments of both sexes in World in 2011 and the Number of enrolments of both sexes in Central African Republic in 2012?
Your response must be concise. 5.53e+08. What is the difference between the Number of enrolments of both sexes in World in 2011 and the Number of enrolments of both sexes in United Kingdom in 2012?
Offer a terse response. 5.49e+08. What is the difference between the Number of enrolments of both sexes in Bhutan in 2011 and the Number of enrolments of both sexes in Central African Republic in 2012?
Offer a terse response. -6.31e+04. What is the difference between the Number of enrolments of both sexes of Bhutan in 2011 and the Number of enrolments of both sexes of United Kingdom in 2012?
Keep it short and to the point. -4.79e+06. What is the difference between the Number of enrolments of both sexes of Central African Republic in 2011 and the Number of enrolments of both sexes of United Kingdom in 2012?
Provide a succinct answer. -4.72e+06. What is the average Number of enrolments of both sexes of World per year?
Offer a terse response. 4.09e+08. What is the average Number of enrolments of both sexes in Bhutan per year?
Provide a short and direct response. 2.90e+04. What is the average Number of enrolments of both sexes in Central African Republic per year?
Your response must be concise. 7.60e+04. What is the average Number of enrolments of both sexes in United Kingdom per year?
Give a very brief answer. 5.20e+06. In the year 1977, what is the difference between the Number of enrolments of both sexes of World and Number of enrolments of both sexes of Bhutan?
Offer a terse response. 2.66e+08. In the year 1977, what is the difference between the Number of enrolments of both sexes in World and Number of enrolments of both sexes in Central African Republic?
Give a very brief answer. 2.66e+08. In the year 1977, what is the difference between the Number of enrolments of both sexes in World and Number of enrolments of both sexes in United Kingdom?
Provide a short and direct response. 2.61e+08. In the year 1977, what is the difference between the Number of enrolments of both sexes in Bhutan and Number of enrolments of both sexes in Central African Republic?
Ensure brevity in your answer.  -2.33e+04. In the year 1977, what is the difference between the Number of enrolments of both sexes of Bhutan and Number of enrolments of both sexes of United Kingdom?
Keep it short and to the point. -5.28e+06. In the year 1977, what is the difference between the Number of enrolments of both sexes of Central African Republic and Number of enrolments of both sexes of United Kingdom?
Ensure brevity in your answer.  -5.26e+06. In the year 1982, what is the difference between the Number of enrolments of both sexes in World and Number of enrolments of both sexes in Bhutan?
Offer a very short reply. 2.95e+08. In the year 1982, what is the difference between the Number of enrolments of both sexes of World and Number of enrolments of both sexes of Central African Republic?
Make the answer very short. 2.95e+08. In the year 1982, what is the difference between the Number of enrolments of both sexes of World and Number of enrolments of both sexes of United Kingdom?
Offer a terse response. 2.90e+08. In the year 1982, what is the difference between the Number of enrolments of both sexes in Bhutan and Number of enrolments of both sexes in Central African Republic?
Offer a very short reply. -5.00e+04. In the year 1982, what is the difference between the Number of enrolments of both sexes in Bhutan and Number of enrolments of both sexes in United Kingdom?
Your answer should be very brief. -5.32e+06. In the year 1982, what is the difference between the Number of enrolments of both sexes of Central African Republic and Number of enrolments of both sexes of United Kingdom?
Your answer should be very brief. -5.27e+06. In the year 1983, what is the difference between the Number of enrolments of both sexes in World and Number of enrolments of both sexes in Bhutan?
Keep it short and to the point. 3.00e+08. In the year 1983, what is the difference between the Number of enrolments of both sexes in World and Number of enrolments of both sexes in Central African Republic?
Ensure brevity in your answer.  3.00e+08. In the year 1983, what is the difference between the Number of enrolments of both sexes in World and Number of enrolments of both sexes in United Kingdom?
Make the answer very short. 2.94e+08. In the year 1983, what is the difference between the Number of enrolments of both sexes of Bhutan and Number of enrolments of both sexes of Central African Republic?
Make the answer very short. -5.01e+04. In the year 1983, what is the difference between the Number of enrolments of both sexes in Bhutan and Number of enrolments of both sexes in United Kingdom?
Your answer should be very brief. -5.29e+06. In the year 1983, what is the difference between the Number of enrolments of both sexes of Central African Republic and Number of enrolments of both sexes of United Kingdom?
Offer a terse response. -5.24e+06. In the year 1985, what is the difference between the Number of enrolments of both sexes in World and Number of enrolments of both sexes in Bhutan?
Ensure brevity in your answer.  3.04e+08. In the year 1985, what is the difference between the Number of enrolments of both sexes of World and Number of enrolments of both sexes of Central African Republic?
Ensure brevity in your answer.  3.04e+08. In the year 1985, what is the difference between the Number of enrolments of both sexes of World and Number of enrolments of both sexes of United Kingdom?
Make the answer very short. 2.99e+08. In the year 1985, what is the difference between the Number of enrolments of both sexes of Bhutan and Number of enrolments of both sexes of Central African Republic?
Keep it short and to the point. -5.20e+04. In the year 1985, what is the difference between the Number of enrolments of both sexes of Bhutan and Number of enrolments of both sexes of United Kingdom?
Provide a short and direct response. -5.02e+06. In the year 1985, what is the difference between the Number of enrolments of both sexes in Central African Republic and Number of enrolments of both sexes in United Kingdom?
Your response must be concise. -4.97e+06. In the year 2001, what is the difference between the Number of enrolments of both sexes in World and Number of enrolments of both sexes in Bhutan?
Offer a terse response. 4.62e+08. In the year 2001, what is the difference between the Number of enrolments of both sexes of World and Number of enrolments of both sexes of Central African Republic?
Make the answer very short. 4.62e+08. In the year 2001, what is the difference between the Number of enrolments of both sexes in World and Number of enrolments of both sexes in United Kingdom?
Provide a short and direct response. 4.57e+08. In the year 2001, what is the difference between the Number of enrolments of both sexes in Bhutan and Number of enrolments of both sexes in Central African Republic?
Provide a succinct answer. -4.10e+04. In the year 2001, what is the difference between the Number of enrolments of both sexes of Bhutan and Number of enrolments of both sexes of United Kingdom?
Your answer should be very brief. -5.35e+06. In the year 2001, what is the difference between the Number of enrolments of both sexes of Central African Republic and Number of enrolments of both sexes of United Kingdom?
Make the answer very short. -5.31e+06. In the year 2009, what is the difference between the Number of enrolments of both sexes of World and Number of enrolments of both sexes of Bhutan?
Keep it short and to the point. 5.34e+08. In the year 2009, what is the difference between the Number of enrolments of both sexes in World and Number of enrolments of both sexes in Central African Republic?
Keep it short and to the point. 5.34e+08. In the year 2009, what is the difference between the Number of enrolments of both sexes of World and Number of enrolments of both sexes of United Kingdom?
Your answer should be very brief. 5.29e+08. In the year 2009, what is the difference between the Number of enrolments of both sexes of Bhutan and Number of enrolments of both sexes of Central African Republic?
Give a very brief answer. -3.68e+04. In the year 2009, what is the difference between the Number of enrolments of both sexes in Bhutan and Number of enrolments of both sexes in United Kingdom?
Keep it short and to the point. -5.37e+06. In the year 2009, what is the difference between the Number of enrolments of both sexes in Central African Republic and Number of enrolments of both sexes in United Kingdom?
Ensure brevity in your answer.  -5.34e+06. In the year 2011, what is the difference between the Number of enrolments of both sexes of World and Number of enrolments of both sexes of Bhutan?
Your answer should be very brief. 5.53e+08. In the year 2011, what is the difference between the Number of enrolments of both sexes in World and Number of enrolments of both sexes in Central African Republic?
Your answer should be very brief. 5.53e+08. In the year 2011, what is the difference between the Number of enrolments of both sexes of World and Number of enrolments of both sexes of United Kingdom?
Your answer should be very brief. 5.48e+08. In the year 2011, what is the difference between the Number of enrolments of both sexes of Bhutan and Number of enrolments of both sexes of Central African Republic?
Offer a terse response. -6.32e+04. In the year 2011, what is the difference between the Number of enrolments of both sexes of Bhutan and Number of enrolments of both sexes of United Kingdom?
Offer a very short reply. -4.94e+06. In the year 2011, what is the difference between the Number of enrolments of both sexes of Central African Republic and Number of enrolments of both sexes of United Kingdom?
Offer a very short reply. -4.87e+06. In the year 2012, what is the difference between the Number of enrolments of both sexes of World and Number of enrolments of both sexes of Bhutan?
Offer a terse response. 5.60e+08. In the year 2012, what is the difference between the Number of enrolments of both sexes of World and Number of enrolments of both sexes of Central African Republic?
Provide a short and direct response. 5.60e+08. In the year 2012, what is the difference between the Number of enrolments of both sexes of World and Number of enrolments of both sexes of United Kingdom?
Offer a very short reply. 5.55e+08. In the year 2012, what is the difference between the Number of enrolments of both sexes of Bhutan and Number of enrolments of both sexes of Central African Republic?
Offer a very short reply. -5.98e+04. In the year 2012, what is the difference between the Number of enrolments of both sexes in Bhutan and Number of enrolments of both sexes in United Kingdom?
Ensure brevity in your answer.  -4.78e+06. In the year 2012, what is the difference between the Number of enrolments of both sexes in Central African Republic and Number of enrolments of both sexes in United Kingdom?
Keep it short and to the point. -4.72e+06. What is the ratio of the Number of enrolments of both sexes of World in 1977 to that in 1982?
Your answer should be very brief. 0.9. What is the ratio of the Number of enrolments of both sexes in Bhutan in 1977 to that in 1982?
Provide a succinct answer. 0.35. What is the ratio of the Number of enrolments of both sexes in Central African Republic in 1977 to that in 1982?
Make the answer very short. 0.46. What is the ratio of the Number of enrolments of both sexes of United Kingdom in 1977 to that in 1982?
Provide a short and direct response. 0.99. What is the ratio of the Number of enrolments of both sexes in World in 1977 to that in 1983?
Provide a succinct answer. 0.89. What is the ratio of the Number of enrolments of both sexes of Bhutan in 1977 to that in 1983?
Ensure brevity in your answer.  0.29. What is the ratio of the Number of enrolments of both sexes in Central African Republic in 1977 to that in 1983?
Make the answer very short. 0.45. What is the ratio of the Number of enrolments of both sexes of United Kingdom in 1977 to that in 1983?
Your answer should be compact. 1. What is the ratio of the Number of enrolments of both sexes of World in 1977 to that in 1985?
Offer a very short reply. 0.88. What is the ratio of the Number of enrolments of both sexes in Bhutan in 1977 to that in 1985?
Give a very brief answer. 0.25. What is the ratio of the Number of enrolments of both sexes in Central African Republic in 1977 to that in 1985?
Offer a terse response. 0.43. What is the ratio of the Number of enrolments of both sexes in United Kingdom in 1977 to that in 1985?
Provide a short and direct response. 1.05. What is the ratio of the Number of enrolments of both sexes of World in 1977 to that in 2001?
Provide a short and direct response. 0.58. What is the ratio of the Number of enrolments of both sexes of Bhutan in 1977 to that in 2001?
Give a very brief answer. 0.05. What is the ratio of the Number of enrolments of both sexes of Central African Republic in 1977 to that in 2001?
Your answer should be very brief. 0.35. What is the ratio of the Number of enrolments of both sexes of United Kingdom in 1977 to that in 2001?
Offer a very short reply. 0.98. What is the ratio of the Number of enrolments of both sexes of World in 1977 to that in 2009?
Your answer should be very brief. 0.5. What is the ratio of the Number of enrolments of both sexes of Bhutan in 1977 to that in 2009?
Give a very brief answer. 0.03. What is the ratio of the Number of enrolments of both sexes in Central African Republic in 1977 to that in 2009?
Provide a succinct answer. 0.27. What is the ratio of the Number of enrolments of both sexes in United Kingdom in 1977 to that in 2009?
Ensure brevity in your answer.  0.97. What is the ratio of the Number of enrolments of both sexes of World in 1977 to that in 2011?
Give a very brief answer. 0.48. What is the ratio of the Number of enrolments of both sexes of Bhutan in 1977 to that in 2011?
Make the answer very short. 0.02. What is the ratio of the Number of enrolments of both sexes in Central African Republic in 1977 to that in 2011?
Your answer should be very brief. 0.2. What is the ratio of the Number of enrolments of both sexes of United Kingdom in 1977 to that in 2011?
Offer a terse response. 1.06. What is the ratio of the Number of enrolments of both sexes of World in 1977 to that in 2012?
Offer a terse response. 0.48. What is the ratio of the Number of enrolments of both sexes in Bhutan in 1977 to that in 2012?
Your answer should be very brief. 0.02. What is the ratio of the Number of enrolments of both sexes in Central African Republic in 1977 to that in 2012?
Provide a succinct answer. 0.2. What is the ratio of the Number of enrolments of both sexes in United Kingdom in 1977 to that in 2012?
Offer a very short reply. 1.09. What is the ratio of the Number of enrolments of both sexes in World in 1982 to that in 1983?
Keep it short and to the point. 0.99. What is the ratio of the Number of enrolments of both sexes of Bhutan in 1982 to that in 1983?
Keep it short and to the point. 0.83. What is the ratio of the Number of enrolments of both sexes of Central African Republic in 1982 to that in 1983?
Provide a succinct answer. 0.98. What is the ratio of the Number of enrolments of both sexes in World in 1982 to that in 1985?
Ensure brevity in your answer.  0.97. What is the ratio of the Number of enrolments of both sexes of Bhutan in 1982 to that in 1985?
Make the answer very short. 0.72. What is the ratio of the Number of enrolments of both sexes in Central African Republic in 1982 to that in 1985?
Your response must be concise. 0.94. What is the ratio of the Number of enrolments of both sexes of United Kingdom in 1982 to that in 1985?
Offer a very short reply. 1.06. What is the ratio of the Number of enrolments of both sexes of World in 1982 to that in 2001?
Provide a succinct answer. 0.64. What is the ratio of the Number of enrolments of both sexes of Bhutan in 1982 to that in 2001?
Keep it short and to the point. 0.15. What is the ratio of the Number of enrolments of both sexes of Central African Republic in 1982 to that in 2001?
Ensure brevity in your answer.  0.78. What is the ratio of the Number of enrolments of both sexes in World in 1982 to that in 2009?
Provide a succinct answer. 0.55. What is the ratio of the Number of enrolments of both sexes in Bhutan in 1982 to that in 2009?
Provide a short and direct response. 0.08. What is the ratio of the Number of enrolments of both sexes in Central African Republic in 1982 to that in 2009?
Offer a very short reply. 0.58. What is the ratio of the Number of enrolments of both sexes of United Kingdom in 1982 to that in 2009?
Your response must be concise. 0.98. What is the ratio of the Number of enrolments of both sexes of World in 1982 to that in 2011?
Offer a very short reply. 0.53. What is the ratio of the Number of enrolments of both sexes of Bhutan in 1982 to that in 2011?
Make the answer very short. 0.07. What is the ratio of the Number of enrolments of both sexes of Central African Republic in 1982 to that in 2011?
Offer a terse response. 0.43. What is the ratio of the Number of enrolments of both sexes of United Kingdom in 1982 to that in 2011?
Your response must be concise. 1.07. What is the ratio of the Number of enrolments of both sexes in World in 1982 to that in 2012?
Provide a short and direct response. 0.53. What is the ratio of the Number of enrolments of both sexes of Bhutan in 1982 to that in 2012?
Give a very brief answer. 0.07. What is the ratio of the Number of enrolments of both sexes of Central African Republic in 1982 to that in 2012?
Ensure brevity in your answer.  0.43. What is the ratio of the Number of enrolments of both sexes of United Kingdom in 1982 to that in 2012?
Your answer should be very brief. 1.1. What is the ratio of the Number of enrolments of both sexes of World in 1983 to that in 1985?
Offer a terse response. 0.98. What is the ratio of the Number of enrolments of both sexes of Bhutan in 1983 to that in 1985?
Ensure brevity in your answer.  0.87. What is the ratio of the Number of enrolments of both sexes of Central African Republic in 1983 to that in 1985?
Offer a terse response. 0.95. What is the ratio of the Number of enrolments of both sexes in United Kingdom in 1983 to that in 1985?
Your response must be concise. 1.05. What is the ratio of the Number of enrolments of both sexes in World in 1983 to that in 2001?
Keep it short and to the point. 0.65. What is the ratio of the Number of enrolments of both sexes in Bhutan in 1983 to that in 2001?
Your answer should be compact. 0.18. What is the ratio of the Number of enrolments of both sexes of Central African Republic in 1983 to that in 2001?
Provide a short and direct response. 0.79. What is the ratio of the Number of enrolments of both sexes of United Kingdom in 1983 to that in 2001?
Your answer should be very brief. 0.98. What is the ratio of the Number of enrolments of both sexes of World in 1983 to that in 2009?
Your answer should be compact. 0.56. What is the ratio of the Number of enrolments of both sexes in Bhutan in 1983 to that in 2009?
Your answer should be very brief. 0.09. What is the ratio of the Number of enrolments of both sexes of Central African Republic in 1983 to that in 2009?
Provide a succinct answer. 0.59. What is the ratio of the Number of enrolments of both sexes of United Kingdom in 1983 to that in 2009?
Keep it short and to the point. 0.98. What is the ratio of the Number of enrolments of both sexes in World in 1983 to that in 2011?
Ensure brevity in your answer.  0.54. What is the ratio of the Number of enrolments of both sexes of Bhutan in 1983 to that in 2011?
Keep it short and to the point. 0.08. What is the ratio of the Number of enrolments of both sexes of Central African Republic in 1983 to that in 2011?
Your answer should be very brief. 0.44. What is the ratio of the Number of enrolments of both sexes in United Kingdom in 1983 to that in 2011?
Give a very brief answer. 1.06. What is the ratio of the Number of enrolments of both sexes of World in 1983 to that in 2012?
Make the answer very short. 0.53. What is the ratio of the Number of enrolments of both sexes of Bhutan in 1983 to that in 2012?
Your answer should be compact. 0.08. What is the ratio of the Number of enrolments of both sexes of Central African Republic in 1983 to that in 2012?
Provide a succinct answer. 0.44. What is the ratio of the Number of enrolments of both sexes in United Kingdom in 1983 to that in 2012?
Your response must be concise. 1.09. What is the ratio of the Number of enrolments of both sexes in World in 1985 to that in 2001?
Provide a succinct answer. 0.66. What is the ratio of the Number of enrolments of both sexes in Bhutan in 1985 to that in 2001?
Give a very brief answer. 0.21. What is the ratio of the Number of enrolments of both sexes in Central African Republic in 1985 to that in 2001?
Your response must be concise. 0.83. What is the ratio of the Number of enrolments of both sexes of United Kingdom in 1985 to that in 2001?
Keep it short and to the point. 0.93. What is the ratio of the Number of enrolments of both sexes of World in 1985 to that in 2009?
Offer a terse response. 0.57. What is the ratio of the Number of enrolments of both sexes in Bhutan in 1985 to that in 2009?
Keep it short and to the point. 0.11. What is the ratio of the Number of enrolments of both sexes in Central African Republic in 1985 to that in 2009?
Ensure brevity in your answer.  0.62. What is the ratio of the Number of enrolments of both sexes of United Kingdom in 1985 to that in 2009?
Your answer should be compact. 0.93. What is the ratio of the Number of enrolments of both sexes in World in 1985 to that in 2011?
Ensure brevity in your answer.  0.55. What is the ratio of the Number of enrolments of both sexes of Bhutan in 1985 to that in 2011?
Give a very brief answer. 0.1. What is the ratio of the Number of enrolments of both sexes of Central African Republic in 1985 to that in 2011?
Your response must be concise. 0.46. What is the ratio of the Number of enrolments of both sexes of World in 1985 to that in 2012?
Give a very brief answer. 0.54. What is the ratio of the Number of enrolments of both sexes of Bhutan in 1985 to that in 2012?
Offer a terse response. 0.09. What is the ratio of the Number of enrolments of both sexes in Central African Republic in 1985 to that in 2012?
Provide a short and direct response. 0.46. What is the ratio of the Number of enrolments of both sexes of United Kingdom in 1985 to that in 2012?
Provide a succinct answer. 1.04. What is the ratio of the Number of enrolments of both sexes in World in 2001 to that in 2009?
Give a very brief answer. 0.87. What is the ratio of the Number of enrolments of both sexes in Bhutan in 2001 to that in 2009?
Your response must be concise. 0.51. What is the ratio of the Number of enrolments of both sexes of Central African Republic in 2001 to that in 2009?
Provide a short and direct response. 0.75. What is the ratio of the Number of enrolments of both sexes of United Kingdom in 2001 to that in 2009?
Provide a succinct answer. 0.99. What is the ratio of the Number of enrolments of both sexes in World in 2001 to that in 2011?
Your answer should be compact. 0.84. What is the ratio of the Number of enrolments of both sexes of Bhutan in 2001 to that in 2011?
Provide a short and direct response. 0.46. What is the ratio of the Number of enrolments of both sexes of Central African Republic in 2001 to that in 2011?
Provide a succinct answer. 0.56. What is the ratio of the Number of enrolments of both sexes in United Kingdom in 2001 to that in 2011?
Give a very brief answer. 1.08. What is the ratio of the Number of enrolments of both sexes of World in 2001 to that in 2012?
Provide a short and direct response. 0.83. What is the ratio of the Number of enrolments of both sexes in Bhutan in 2001 to that in 2012?
Provide a succinct answer. 0.44. What is the ratio of the Number of enrolments of both sexes in Central African Republic in 2001 to that in 2012?
Ensure brevity in your answer.  0.56. What is the ratio of the Number of enrolments of both sexes of United Kingdom in 2001 to that in 2012?
Offer a terse response. 1.11. What is the ratio of the Number of enrolments of both sexes in World in 2009 to that in 2011?
Offer a terse response. 0.97. What is the ratio of the Number of enrolments of both sexes of Bhutan in 2009 to that in 2011?
Give a very brief answer. 0.9. What is the ratio of the Number of enrolments of both sexes of Central African Republic in 2009 to that in 2011?
Your answer should be compact. 0.74. What is the ratio of the Number of enrolments of both sexes of United Kingdom in 2009 to that in 2011?
Your response must be concise. 1.09. What is the ratio of the Number of enrolments of both sexes in World in 2009 to that in 2012?
Offer a very short reply. 0.95. What is the ratio of the Number of enrolments of both sexes of Bhutan in 2009 to that in 2012?
Ensure brevity in your answer.  0.86. What is the ratio of the Number of enrolments of both sexes in Central African Republic in 2009 to that in 2012?
Ensure brevity in your answer.  0.74. What is the ratio of the Number of enrolments of both sexes in United Kingdom in 2009 to that in 2012?
Provide a short and direct response. 1.12. What is the ratio of the Number of enrolments of both sexes in Central African Republic in 2011 to that in 2012?
Give a very brief answer. 1. What is the ratio of the Number of enrolments of both sexes of United Kingdom in 2011 to that in 2012?
Provide a succinct answer. 1.03. What is the difference between the highest and the second highest Number of enrolments of both sexes in World?
Your answer should be very brief. 6.84e+06. What is the difference between the highest and the second highest Number of enrolments of both sexes in Bhutan?
Make the answer very short. 3304. What is the difference between the highest and the second highest Number of enrolments of both sexes of Central African Republic?
Your answer should be very brief. 110. What is the difference between the highest and the second highest Number of enrolments of both sexes in United Kingdom?
Provide a succinct answer. 5.27e+04. What is the difference between the highest and the lowest Number of enrolments of both sexes in World?
Offer a terse response. 2.94e+08. What is the difference between the highest and the lowest Number of enrolments of both sexes in Bhutan?
Your response must be concise. 6.45e+04. What is the difference between the highest and the lowest Number of enrolments of both sexes in Central African Republic?
Keep it short and to the point. 1.01e+05. What is the difference between the highest and the lowest Number of enrolments of both sexes of United Kingdom?
Ensure brevity in your answer.  5.80e+05. 